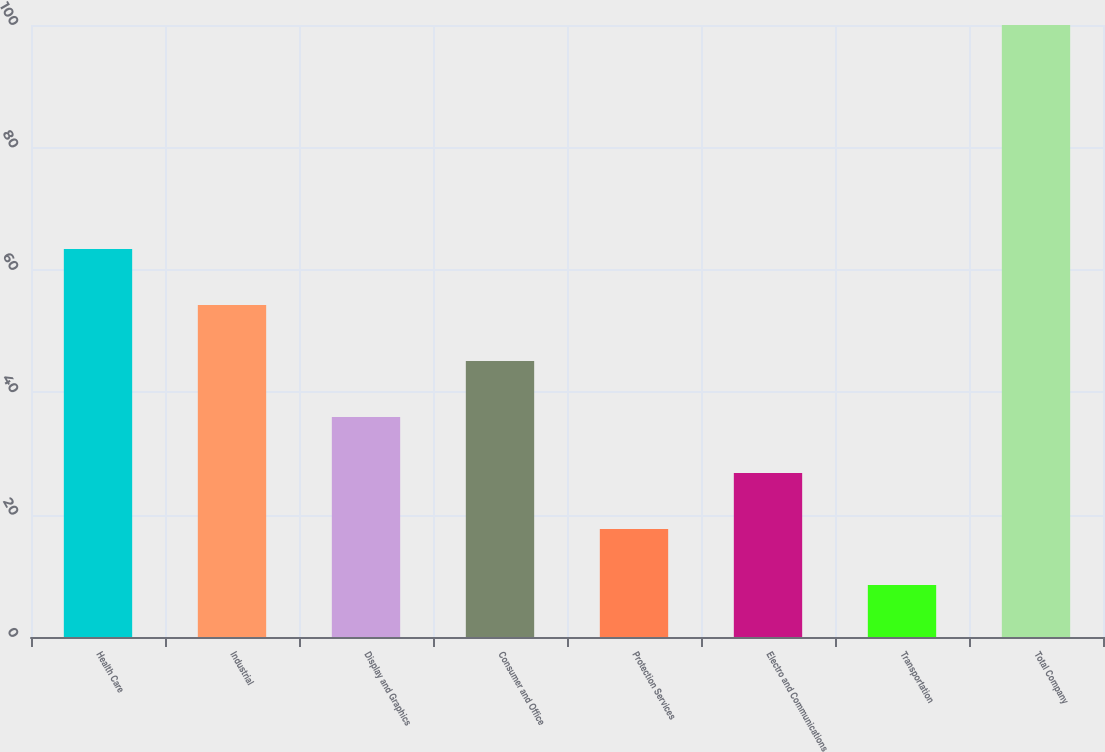Convert chart. <chart><loc_0><loc_0><loc_500><loc_500><bar_chart><fcel>Health Care<fcel>Industrial<fcel>Display and Graphics<fcel>Consumer and Office<fcel>Protection Services<fcel>Electro and Communications<fcel>Transportation<fcel>Total Company<nl><fcel>63.4<fcel>54.25<fcel>35.95<fcel>45.1<fcel>17.65<fcel>26.8<fcel>8.5<fcel>100<nl></chart> 